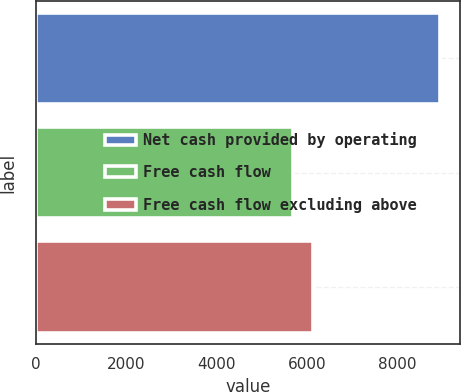Convert chart to OTSL. <chart><loc_0><loc_0><loc_500><loc_500><bar_chart><fcel>Net cash provided by operating<fcel>Free cash flow<fcel>Free cash flow excluding above<nl><fcel>8944<fcel>5689<fcel>6145<nl></chart> 